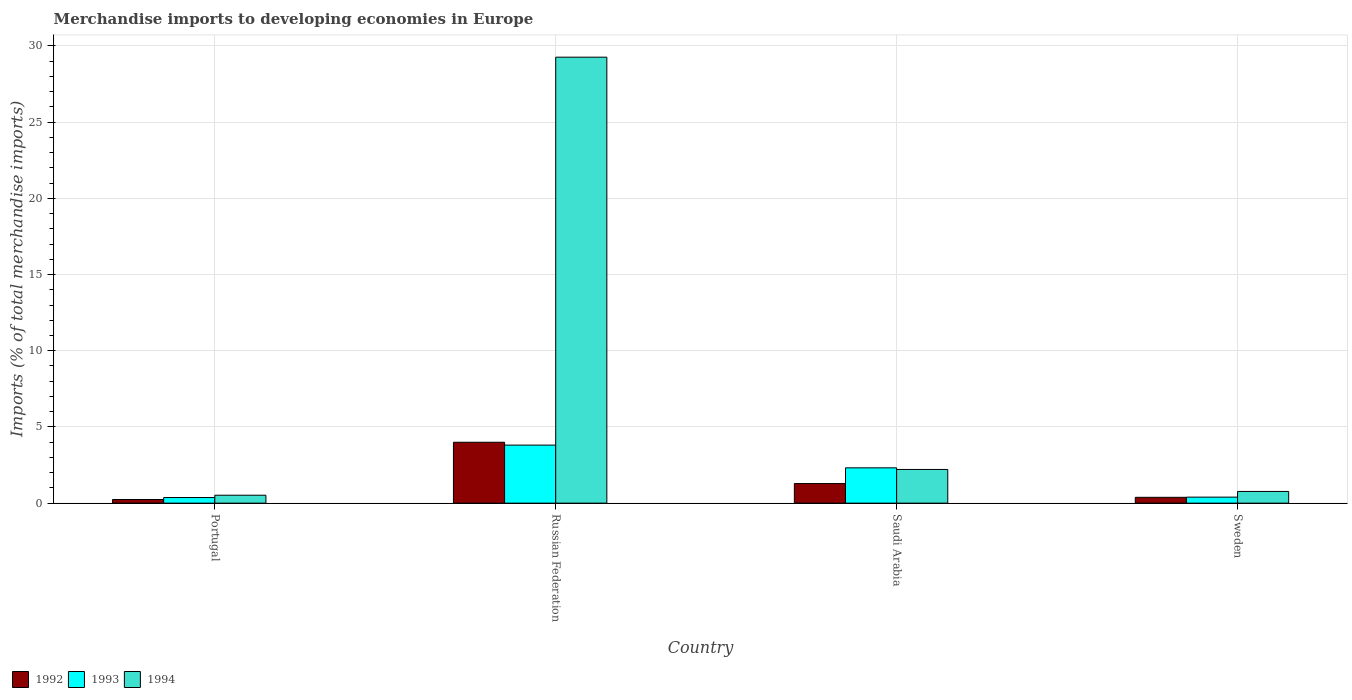How many different coloured bars are there?
Make the answer very short. 3. How many groups of bars are there?
Keep it short and to the point. 4. Are the number of bars on each tick of the X-axis equal?
Provide a succinct answer. Yes. How many bars are there on the 3rd tick from the left?
Your answer should be compact. 3. What is the label of the 2nd group of bars from the left?
Your response must be concise. Russian Federation. What is the percentage total merchandise imports in 1993 in Russian Federation?
Provide a short and direct response. 3.81. Across all countries, what is the maximum percentage total merchandise imports in 1992?
Offer a terse response. 4. Across all countries, what is the minimum percentage total merchandise imports in 1994?
Make the answer very short. 0.52. In which country was the percentage total merchandise imports in 1994 maximum?
Give a very brief answer. Russian Federation. In which country was the percentage total merchandise imports in 1994 minimum?
Make the answer very short. Portugal. What is the total percentage total merchandise imports in 1993 in the graph?
Your answer should be compact. 6.89. What is the difference between the percentage total merchandise imports in 1992 in Russian Federation and that in Sweden?
Make the answer very short. 3.61. What is the difference between the percentage total merchandise imports in 1994 in Portugal and the percentage total merchandise imports in 1993 in Russian Federation?
Offer a terse response. -3.29. What is the average percentage total merchandise imports in 1993 per country?
Offer a very short reply. 1.72. What is the difference between the percentage total merchandise imports of/in 1994 and percentage total merchandise imports of/in 1993 in Sweden?
Offer a very short reply. 0.37. What is the ratio of the percentage total merchandise imports in 1992 in Russian Federation to that in Saudi Arabia?
Provide a succinct answer. 3.11. Is the percentage total merchandise imports in 1993 in Portugal less than that in Saudi Arabia?
Your response must be concise. Yes. What is the difference between the highest and the second highest percentage total merchandise imports in 1992?
Offer a very short reply. -0.9. What is the difference between the highest and the lowest percentage total merchandise imports in 1992?
Your answer should be compact. 3.76. Is the sum of the percentage total merchandise imports in 1994 in Russian Federation and Saudi Arabia greater than the maximum percentage total merchandise imports in 1992 across all countries?
Provide a short and direct response. Yes. What does the 3rd bar from the right in Sweden represents?
Your answer should be compact. 1992. Is it the case that in every country, the sum of the percentage total merchandise imports in 1994 and percentage total merchandise imports in 1993 is greater than the percentage total merchandise imports in 1992?
Keep it short and to the point. Yes. How many bars are there?
Keep it short and to the point. 12. Are all the bars in the graph horizontal?
Offer a very short reply. No. Are the values on the major ticks of Y-axis written in scientific E-notation?
Provide a succinct answer. No. Does the graph contain grids?
Your answer should be compact. Yes. Where does the legend appear in the graph?
Offer a terse response. Bottom left. How many legend labels are there?
Keep it short and to the point. 3. How are the legend labels stacked?
Your answer should be very brief. Horizontal. What is the title of the graph?
Give a very brief answer. Merchandise imports to developing economies in Europe. Does "1963" appear as one of the legend labels in the graph?
Make the answer very short. No. What is the label or title of the Y-axis?
Offer a terse response. Imports (% of total merchandise imports). What is the Imports (% of total merchandise imports) in 1992 in Portugal?
Ensure brevity in your answer.  0.24. What is the Imports (% of total merchandise imports) of 1993 in Portugal?
Provide a succinct answer. 0.37. What is the Imports (% of total merchandise imports) in 1994 in Portugal?
Provide a succinct answer. 0.52. What is the Imports (% of total merchandise imports) in 1992 in Russian Federation?
Your response must be concise. 4. What is the Imports (% of total merchandise imports) in 1993 in Russian Federation?
Your answer should be compact. 3.81. What is the Imports (% of total merchandise imports) of 1994 in Russian Federation?
Give a very brief answer. 29.26. What is the Imports (% of total merchandise imports) of 1992 in Saudi Arabia?
Keep it short and to the point. 1.29. What is the Imports (% of total merchandise imports) in 1993 in Saudi Arabia?
Your response must be concise. 2.32. What is the Imports (% of total merchandise imports) of 1994 in Saudi Arabia?
Give a very brief answer. 2.21. What is the Imports (% of total merchandise imports) in 1992 in Sweden?
Offer a very short reply. 0.38. What is the Imports (% of total merchandise imports) in 1993 in Sweden?
Ensure brevity in your answer.  0.39. What is the Imports (% of total merchandise imports) in 1994 in Sweden?
Make the answer very short. 0.77. Across all countries, what is the maximum Imports (% of total merchandise imports) of 1992?
Keep it short and to the point. 4. Across all countries, what is the maximum Imports (% of total merchandise imports) of 1993?
Provide a succinct answer. 3.81. Across all countries, what is the maximum Imports (% of total merchandise imports) in 1994?
Ensure brevity in your answer.  29.26. Across all countries, what is the minimum Imports (% of total merchandise imports) in 1992?
Ensure brevity in your answer.  0.24. Across all countries, what is the minimum Imports (% of total merchandise imports) in 1993?
Make the answer very short. 0.37. Across all countries, what is the minimum Imports (% of total merchandise imports) in 1994?
Give a very brief answer. 0.52. What is the total Imports (% of total merchandise imports) of 1992 in the graph?
Keep it short and to the point. 5.9. What is the total Imports (% of total merchandise imports) of 1993 in the graph?
Your answer should be very brief. 6.89. What is the total Imports (% of total merchandise imports) in 1994 in the graph?
Provide a succinct answer. 32.76. What is the difference between the Imports (% of total merchandise imports) in 1992 in Portugal and that in Russian Federation?
Your answer should be compact. -3.76. What is the difference between the Imports (% of total merchandise imports) in 1993 in Portugal and that in Russian Federation?
Provide a short and direct response. -3.44. What is the difference between the Imports (% of total merchandise imports) in 1994 in Portugal and that in Russian Federation?
Provide a short and direct response. -28.74. What is the difference between the Imports (% of total merchandise imports) of 1992 in Portugal and that in Saudi Arabia?
Offer a very short reply. -1.05. What is the difference between the Imports (% of total merchandise imports) in 1993 in Portugal and that in Saudi Arabia?
Keep it short and to the point. -1.95. What is the difference between the Imports (% of total merchandise imports) of 1994 in Portugal and that in Saudi Arabia?
Keep it short and to the point. -1.69. What is the difference between the Imports (% of total merchandise imports) in 1992 in Portugal and that in Sweden?
Ensure brevity in your answer.  -0.14. What is the difference between the Imports (% of total merchandise imports) of 1993 in Portugal and that in Sweden?
Provide a short and direct response. -0.03. What is the difference between the Imports (% of total merchandise imports) of 1994 in Portugal and that in Sweden?
Provide a succinct answer. -0.25. What is the difference between the Imports (% of total merchandise imports) in 1992 in Russian Federation and that in Saudi Arabia?
Your response must be concise. 2.71. What is the difference between the Imports (% of total merchandise imports) in 1993 in Russian Federation and that in Saudi Arabia?
Give a very brief answer. 1.49. What is the difference between the Imports (% of total merchandise imports) in 1994 in Russian Federation and that in Saudi Arabia?
Make the answer very short. 27.05. What is the difference between the Imports (% of total merchandise imports) in 1992 in Russian Federation and that in Sweden?
Your answer should be compact. 3.61. What is the difference between the Imports (% of total merchandise imports) in 1993 in Russian Federation and that in Sweden?
Offer a very short reply. 3.41. What is the difference between the Imports (% of total merchandise imports) of 1994 in Russian Federation and that in Sweden?
Ensure brevity in your answer.  28.5. What is the difference between the Imports (% of total merchandise imports) of 1992 in Saudi Arabia and that in Sweden?
Give a very brief answer. 0.9. What is the difference between the Imports (% of total merchandise imports) of 1993 in Saudi Arabia and that in Sweden?
Keep it short and to the point. 1.92. What is the difference between the Imports (% of total merchandise imports) of 1994 in Saudi Arabia and that in Sweden?
Provide a short and direct response. 1.44. What is the difference between the Imports (% of total merchandise imports) in 1992 in Portugal and the Imports (% of total merchandise imports) in 1993 in Russian Federation?
Make the answer very short. -3.57. What is the difference between the Imports (% of total merchandise imports) of 1992 in Portugal and the Imports (% of total merchandise imports) of 1994 in Russian Federation?
Your answer should be compact. -29.03. What is the difference between the Imports (% of total merchandise imports) in 1993 in Portugal and the Imports (% of total merchandise imports) in 1994 in Russian Federation?
Ensure brevity in your answer.  -28.9. What is the difference between the Imports (% of total merchandise imports) in 1992 in Portugal and the Imports (% of total merchandise imports) in 1993 in Saudi Arabia?
Give a very brief answer. -2.08. What is the difference between the Imports (% of total merchandise imports) in 1992 in Portugal and the Imports (% of total merchandise imports) in 1994 in Saudi Arabia?
Provide a short and direct response. -1.97. What is the difference between the Imports (% of total merchandise imports) of 1993 in Portugal and the Imports (% of total merchandise imports) of 1994 in Saudi Arabia?
Your response must be concise. -1.84. What is the difference between the Imports (% of total merchandise imports) in 1992 in Portugal and the Imports (% of total merchandise imports) in 1993 in Sweden?
Offer a terse response. -0.16. What is the difference between the Imports (% of total merchandise imports) of 1992 in Portugal and the Imports (% of total merchandise imports) of 1994 in Sweden?
Provide a succinct answer. -0.53. What is the difference between the Imports (% of total merchandise imports) in 1993 in Portugal and the Imports (% of total merchandise imports) in 1994 in Sweden?
Provide a succinct answer. -0.4. What is the difference between the Imports (% of total merchandise imports) in 1992 in Russian Federation and the Imports (% of total merchandise imports) in 1993 in Saudi Arabia?
Offer a terse response. 1.68. What is the difference between the Imports (% of total merchandise imports) in 1992 in Russian Federation and the Imports (% of total merchandise imports) in 1994 in Saudi Arabia?
Your response must be concise. 1.79. What is the difference between the Imports (% of total merchandise imports) of 1993 in Russian Federation and the Imports (% of total merchandise imports) of 1994 in Saudi Arabia?
Your answer should be compact. 1.6. What is the difference between the Imports (% of total merchandise imports) in 1992 in Russian Federation and the Imports (% of total merchandise imports) in 1993 in Sweden?
Your answer should be very brief. 3.6. What is the difference between the Imports (% of total merchandise imports) of 1992 in Russian Federation and the Imports (% of total merchandise imports) of 1994 in Sweden?
Make the answer very short. 3.23. What is the difference between the Imports (% of total merchandise imports) in 1993 in Russian Federation and the Imports (% of total merchandise imports) in 1994 in Sweden?
Give a very brief answer. 3.04. What is the difference between the Imports (% of total merchandise imports) of 1992 in Saudi Arabia and the Imports (% of total merchandise imports) of 1993 in Sweden?
Provide a short and direct response. 0.89. What is the difference between the Imports (% of total merchandise imports) in 1992 in Saudi Arabia and the Imports (% of total merchandise imports) in 1994 in Sweden?
Keep it short and to the point. 0.52. What is the difference between the Imports (% of total merchandise imports) of 1993 in Saudi Arabia and the Imports (% of total merchandise imports) of 1994 in Sweden?
Your answer should be compact. 1.55. What is the average Imports (% of total merchandise imports) of 1992 per country?
Your response must be concise. 1.48. What is the average Imports (% of total merchandise imports) in 1993 per country?
Your answer should be very brief. 1.72. What is the average Imports (% of total merchandise imports) of 1994 per country?
Your answer should be very brief. 8.19. What is the difference between the Imports (% of total merchandise imports) of 1992 and Imports (% of total merchandise imports) of 1993 in Portugal?
Ensure brevity in your answer.  -0.13. What is the difference between the Imports (% of total merchandise imports) in 1992 and Imports (% of total merchandise imports) in 1994 in Portugal?
Make the answer very short. -0.28. What is the difference between the Imports (% of total merchandise imports) of 1993 and Imports (% of total merchandise imports) of 1994 in Portugal?
Provide a succinct answer. -0.15. What is the difference between the Imports (% of total merchandise imports) of 1992 and Imports (% of total merchandise imports) of 1993 in Russian Federation?
Offer a very short reply. 0.19. What is the difference between the Imports (% of total merchandise imports) of 1992 and Imports (% of total merchandise imports) of 1994 in Russian Federation?
Offer a terse response. -25.27. What is the difference between the Imports (% of total merchandise imports) of 1993 and Imports (% of total merchandise imports) of 1994 in Russian Federation?
Your answer should be very brief. -25.46. What is the difference between the Imports (% of total merchandise imports) of 1992 and Imports (% of total merchandise imports) of 1993 in Saudi Arabia?
Your response must be concise. -1.03. What is the difference between the Imports (% of total merchandise imports) of 1992 and Imports (% of total merchandise imports) of 1994 in Saudi Arabia?
Ensure brevity in your answer.  -0.92. What is the difference between the Imports (% of total merchandise imports) of 1993 and Imports (% of total merchandise imports) of 1994 in Saudi Arabia?
Provide a short and direct response. 0.11. What is the difference between the Imports (% of total merchandise imports) in 1992 and Imports (% of total merchandise imports) in 1993 in Sweden?
Offer a very short reply. -0.01. What is the difference between the Imports (% of total merchandise imports) in 1992 and Imports (% of total merchandise imports) in 1994 in Sweden?
Provide a short and direct response. -0.39. What is the difference between the Imports (% of total merchandise imports) of 1993 and Imports (% of total merchandise imports) of 1994 in Sweden?
Make the answer very short. -0.37. What is the ratio of the Imports (% of total merchandise imports) of 1992 in Portugal to that in Russian Federation?
Keep it short and to the point. 0.06. What is the ratio of the Imports (% of total merchandise imports) of 1993 in Portugal to that in Russian Federation?
Ensure brevity in your answer.  0.1. What is the ratio of the Imports (% of total merchandise imports) of 1994 in Portugal to that in Russian Federation?
Give a very brief answer. 0.02. What is the ratio of the Imports (% of total merchandise imports) of 1992 in Portugal to that in Saudi Arabia?
Your answer should be compact. 0.19. What is the ratio of the Imports (% of total merchandise imports) in 1993 in Portugal to that in Saudi Arabia?
Your response must be concise. 0.16. What is the ratio of the Imports (% of total merchandise imports) in 1994 in Portugal to that in Saudi Arabia?
Offer a very short reply. 0.24. What is the ratio of the Imports (% of total merchandise imports) in 1992 in Portugal to that in Sweden?
Keep it short and to the point. 0.62. What is the ratio of the Imports (% of total merchandise imports) of 1993 in Portugal to that in Sweden?
Offer a very short reply. 0.93. What is the ratio of the Imports (% of total merchandise imports) of 1994 in Portugal to that in Sweden?
Your response must be concise. 0.68. What is the ratio of the Imports (% of total merchandise imports) of 1992 in Russian Federation to that in Saudi Arabia?
Provide a short and direct response. 3.11. What is the ratio of the Imports (% of total merchandise imports) of 1993 in Russian Federation to that in Saudi Arabia?
Provide a short and direct response. 1.64. What is the ratio of the Imports (% of total merchandise imports) in 1994 in Russian Federation to that in Saudi Arabia?
Your answer should be compact. 13.24. What is the ratio of the Imports (% of total merchandise imports) of 1992 in Russian Federation to that in Sweden?
Make the answer very short. 10.44. What is the ratio of the Imports (% of total merchandise imports) in 1993 in Russian Federation to that in Sweden?
Ensure brevity in your answer.  9.66. What is the ratio of the Imports (% of total merchandise imports) of 1994 in Russian Federation to that in Sweden?
Your answer should be compact. 38.12. What is the ratio of the Imports (% of total merchandise imports) in 1992 in Saudi Arabia to that in Sweden?
Your answer should be very brief. 3.36. What is the ratio of the Imports (% of total merchandise imports) of 1993 in Saudi Arabia to that in Sweden?
Your answer should be very brief. 5.87. What is the ratio of the Imports (% of total merchandise imports) of 1994 in Saudi Arabia to that in Sweden?
Provide a short and direct response. 2.88. What is the difference between the highest and the second highest Imports (% of total merchandise imports) in 1992?
Keep it short and to the point. 2.71. What is the difference between the highest and the second highest Imports (% of total merchandise imports) of 1993?
Provide a short and direct response. 1.49. What is the difference between the highest and the second highest Imports (% of total merchandise imports) in 1994?
Offer a very short reply. 27.05. What is the difference between the highest and the lowest Imports (% of total merchandise imports) in 1992?
Keep it short and to the point. 3.76. What is the difference between the highest and the lowest Imports (% of total merchandise imports) in 1993?
Give a very brief answer. 3.44. What is the difference between the highest and the lowest Imports (% of total merchandise imports) in 1994?
Your answer should be very brief. 28.74. 